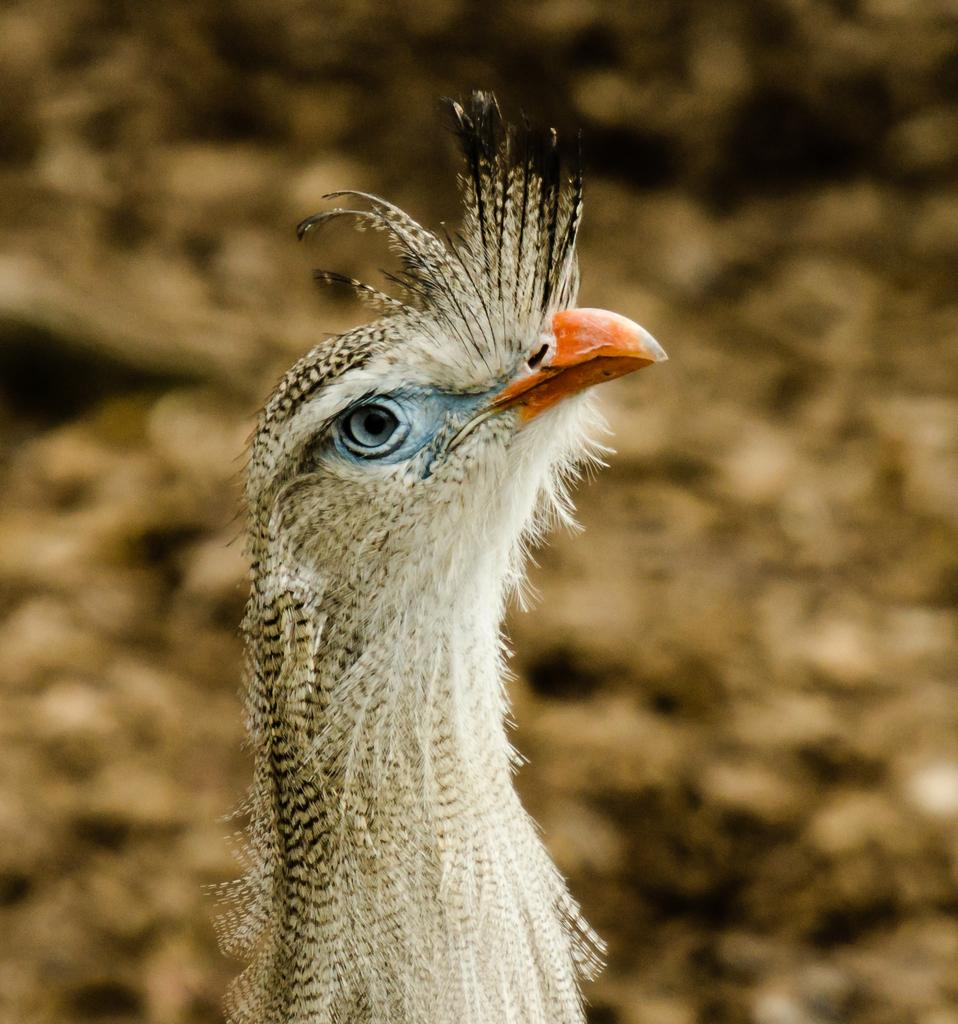What type of animal is present in the image? There is a bird in the image. Can you describe the color pattern of the bird? The bird has a white and black color combination. What can be observed about the background of the image? The background of the image is blurred. How many houses can be seen at the edge of the image? There are no houses present in the image; it features a bird with a white and black color combination against a blurred background. 